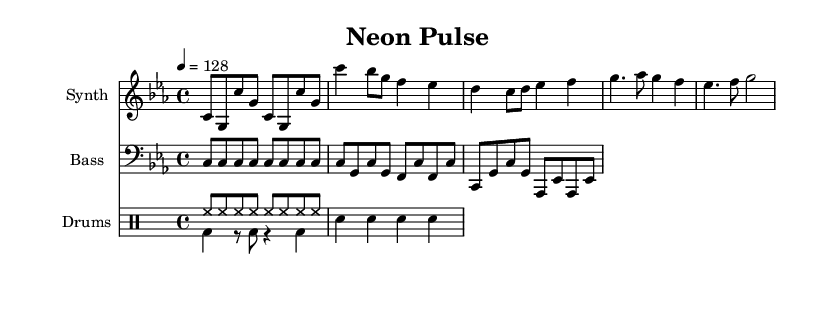What is the key signature of this music? The key signature is indicated at the beginning of the staff and is C minor, which contains three flats (B♭, E♭, A♭).
Answer: C minor What is the time signature used in this composition? The time signature is found at the beginning of the music and is shown as 4/4, which means four beats in a measure.
Answer: 4/4 What is the tempo marking for this piece? The tempo is marked at the beginning, set at a quarter note equals 128 beats per minute, indicating a moderately fast pace.
Answer: 128 How many measures are in the verse section? The verse section contains two measures as identified by the repeated musical phrases and the spacing.
Answer: 2 What is the rhythmic pattern in the drum part? The drum part includes a steady eight-note hi-hat pattern followed by a bass and snare drum alternation, emphasizing the beat in a typical soundtrack setting.
Answer: Hi-hat and bass-snare alternation Which instruments are used in this composition? The instruments are listed at the beginning of each staff: synthesizer, bass, and drums are explicitly stated as the instrument names.
Answer: Synthesizer, Bass, Drums What are the dynamic markings for the chorus section? There are no dynamic markings provided in the given music, indicating that the dynamics are to be interpreted by the performer.
Answer: None 